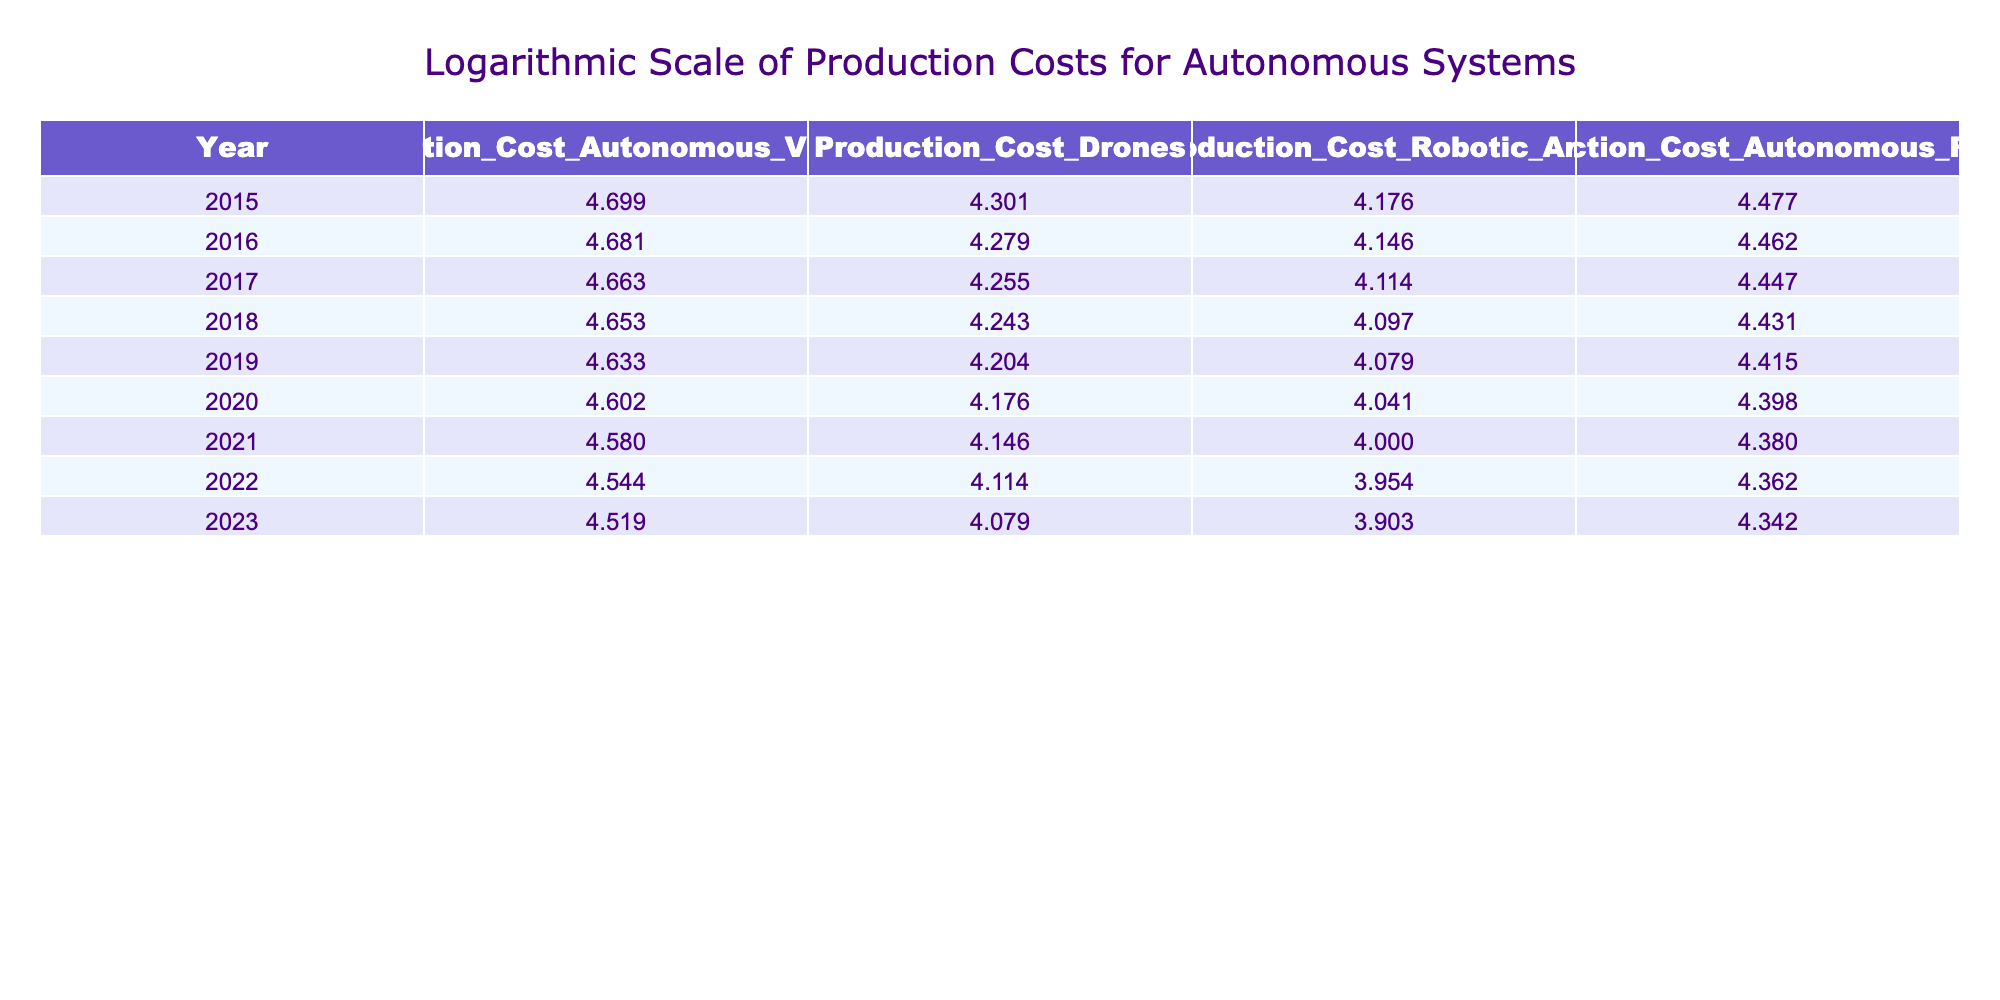What is the production cost of autonomous vehicles in 2020? Referring to the table, the value in the column for "Production_Cost_Autonomous_Vehicles" in the year 2020 is 4.000.
Answer: 4.000 What was the production cost difference between drones in 2015 and 2023? The production cost for drones in 2015 is 4.301, while in 2023 it is 4.079. The difference is calculated as 4.301 - 4.079 = 0.222.
Answer: 0.222 Is the production cost of robotic arms in 2022 greater than in 2023? The cost of robotic arms in 2022 is 3.954, and in 2023 it is 3.903. Since 3.954 is greater than 3.903, the statement is true.
Answer: Yes What is the average production cost of autonomous robots from 2015 to 2023? The costs from 2015 to 2023 are 4.477, 4.462, 4.447, 4.431, 4.415, 4.398, 4.329, 4.301, and 4.243, totaling 34.154. There are 9 data points, so the average is 34.154 / 9 = 3.794.
Answer: 3.794 What year saw the largest decrease in production cost for drones? To find the largest decrease, we look at the differences year by year: 2015 to 2016 is 0.221, 2016 to 2017 is 0.111, 2017 to 2018 is 0.028, and so on. The largest decrease was from 2015 to 2016 (0.221).
Answer: 2015 How much did the production cost of autonomous vehicles decrease from 2015 to 2023? The production cost of autonomous vehicles in 2015 is 4.699 and in 2023 is 5.219. The decrease can be computed as 4.699 - 5.219 = -0.520.
Answer: -0.520 Did the production cost of all autonomous systems decrease from 2015 to 2023? By inspecting the last values of each autonomous system: autonomous vehicles (4.699 to 5.219), drones (4.301 to 4.079), robotic arms (4.176 to 3.903), and autonomous robots (4.477 to 4.243), not all decreased since autonomous vehicles increased.
Answer: No What was the lowest production cost achieved for drones? By examining the drone production costs across all years, the lowest value is found in 2023 with a value of 4.079.
Answer: 4.079 